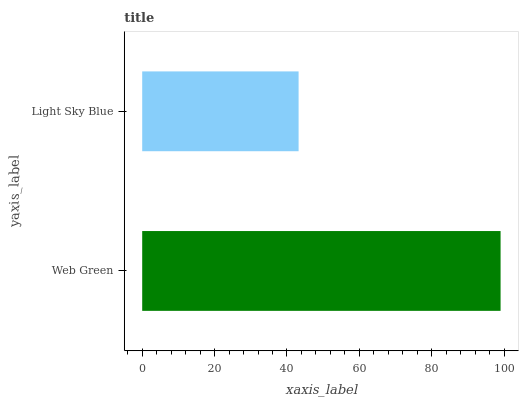Is Light Sky Blue the minimum?
Answer yes or no. Yes. Is Web Green the maximum?
Answer yes or no. Yes. Is Light Sky Blue the maximum?
Answer yes or no. No. Is Web Green greater than Light Sky Blue?
Answer yes or no. Yes. Is Light Sky Blue less than Web Green?
Answer yes or no. Yes. Is Light Sky Blue greater than Web Green?
Answer yes or no. No. Is Web Green less than Light Sky Blue?
Answer yes or no. No. Is Web Green the high median?
Answer yes or no. Yes. Is Light Sky Blue the low median?
Answer yes or no. Yes. Is Light Sky Blue the high median?
Answer yes or no. No. Is Web Green the low median?
Answer yes or no. No. 